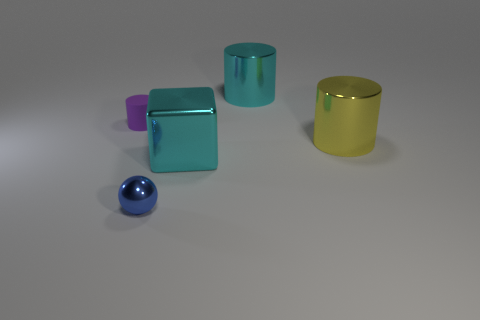Subtract all big shiny cylinders. How many cylinders are left? 1 Subtract all cyan cylinders. How many cylinders are left? 2 Add 4 big blue blocks. How many objects exist? 9 Subtract all cylinders. How many objects are left? 2 Subtract 1 blocks. How many blocks are left? 0 Subtract all green cylinders. Subtract all yellow blocks. How many cylinders are left? 3 Subtract all gray balls. How many blue cylinders are left? 0 Subtract all tiny purple matte balls. Subtract all cyan metallic objects. How many objects are left? 3 Add 4 big yellow shiny cylinders. How many big yellow shiny cylinders are left? 5 Add 5 tiny yellow matte blocks. How many tiny yellow matte blocks exist? 5 